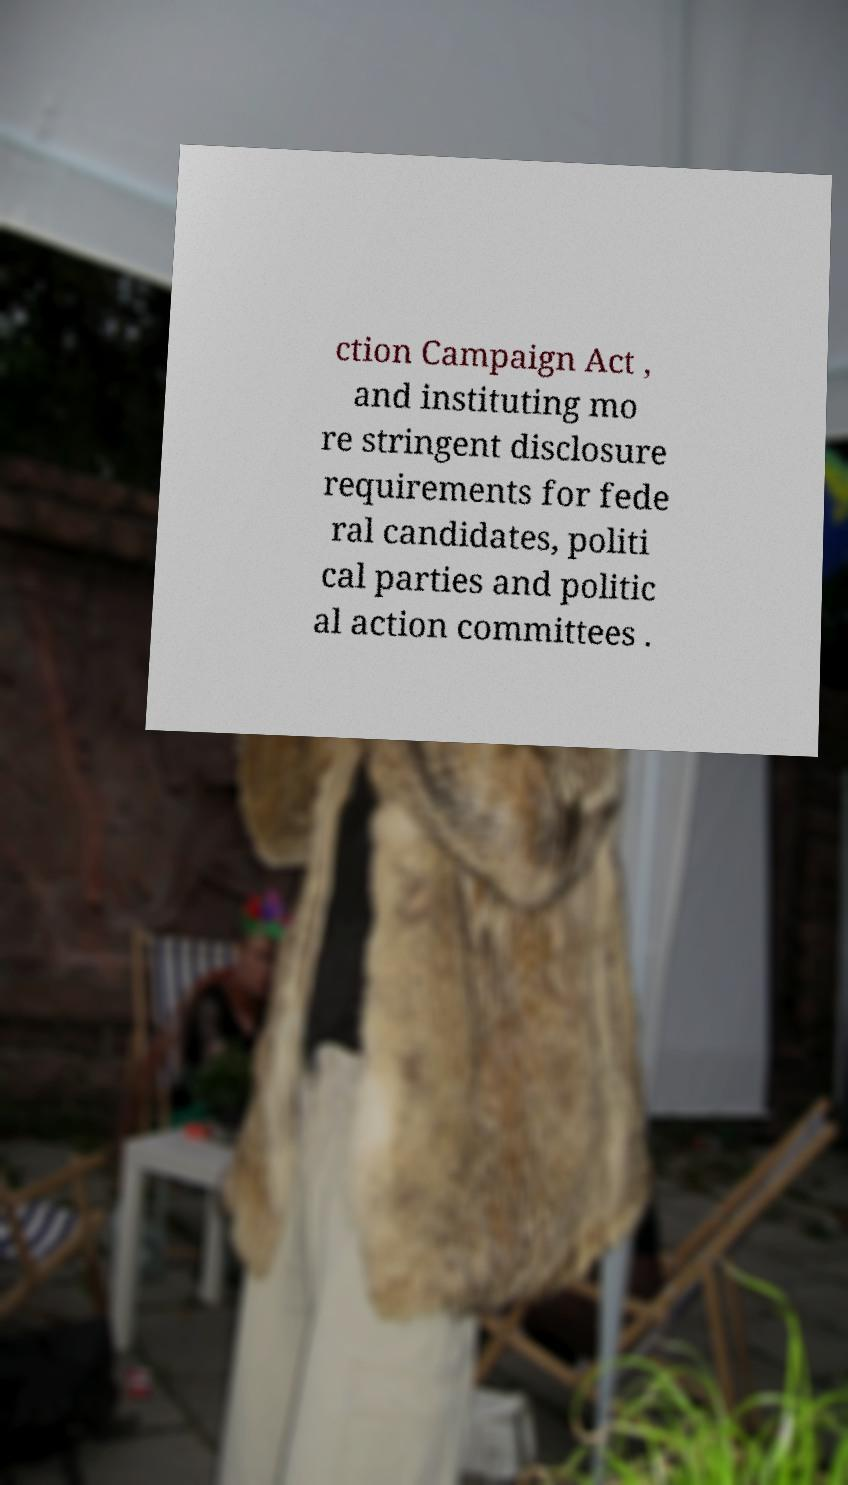Please identify and transcribe the text found in this image. ction Campaign Act , and instituting mo re stringent disclosure requirements for fede ral candidates, politi cal parties and politic al action committees . 